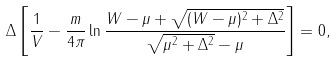Convert formula to latex. <formula><loc_0><loc_0><loc_500><loc_500>\Delta \left [ \frac { 1 } { V } - \frac { m } { 4 \pi } \ln \frac { W - \mu + \sqrt { ( W - \mu ) ^ { 2 } + \Delta ^ { 2 } } } { \sqrt { \mu ^ { 2 } + \Delta ^ { 2 } } - \mu } \right ] = 0 ,</formula> 